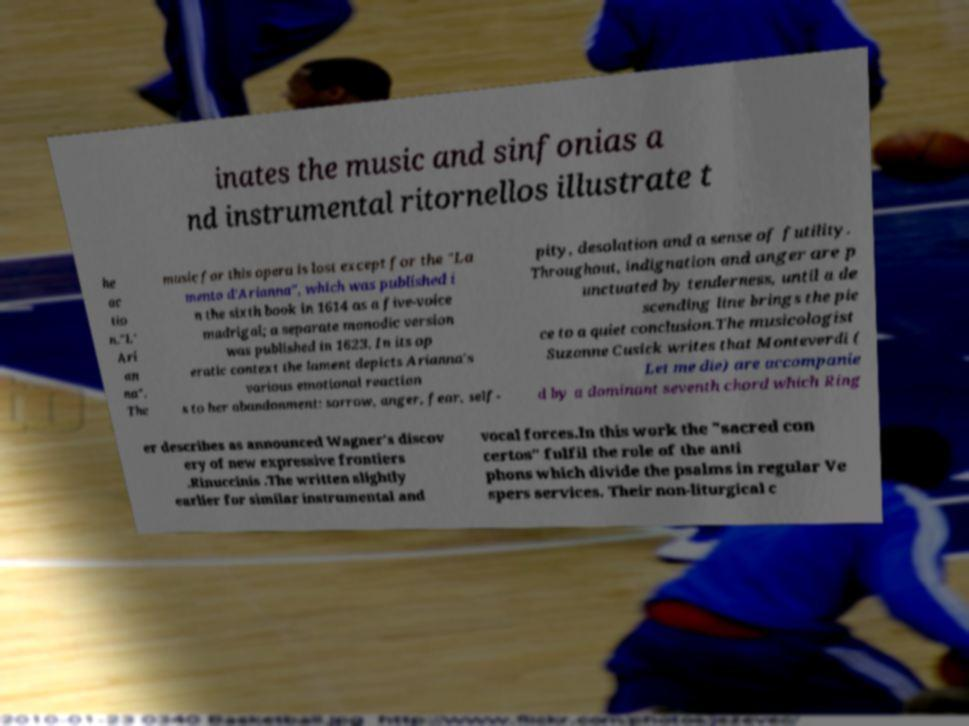What messages or text are displayed in this image? I need them in a readable, typed format. inates the music and sinfonias a nd instrumental ritornellos illustrate t he ac tio n."L' Ari an na". The music for this opera is lost except for the "La mento d'Arianna", which was published i n the sixth book in 1614 as a five-voice madrigal; a separate monodic version was published in 1623. In its op eratic context the lament depicts Arianna's various emotional reaction s to her abandonment: sorrow, anger, fear, self- pity, desolation and a sense of futility. Throughout, indignation and anger are p unctuated by tenderness, until a de scending line brings the pie ce to a quiet conclusion.The musicologist Suzanne Cusick writes that Monteverdi ( Let me die) are accompanie d by a dominant seventh chord which Ring er describes as announced Wagner's discov ery of new expressive frontiers .Rinuccinis .The written slightly earlier for similar instrumental and vocal forces.In this work the "sacred con certos" fulfil the role of the anti phons which divide the psalms in regular Ve spers services. Their non-liturgical c 